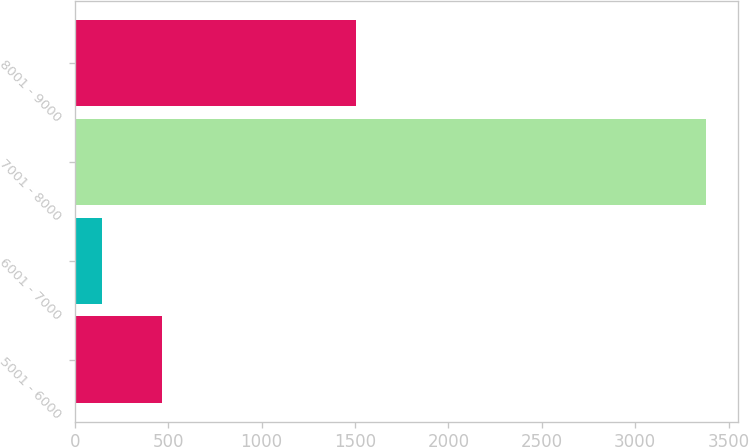Convert chart to OTSL. <chart><loc_0><loc_0><loc_500><loc_500><bar_chart><fcel>5001 - 6000<fcel>6001 - 7000<fcel>7001 - 8000<fcel>8001 - 9000<nl><fcel>467.6<fcel>144<fcel>3380<fcel>1503<nl></chart> 